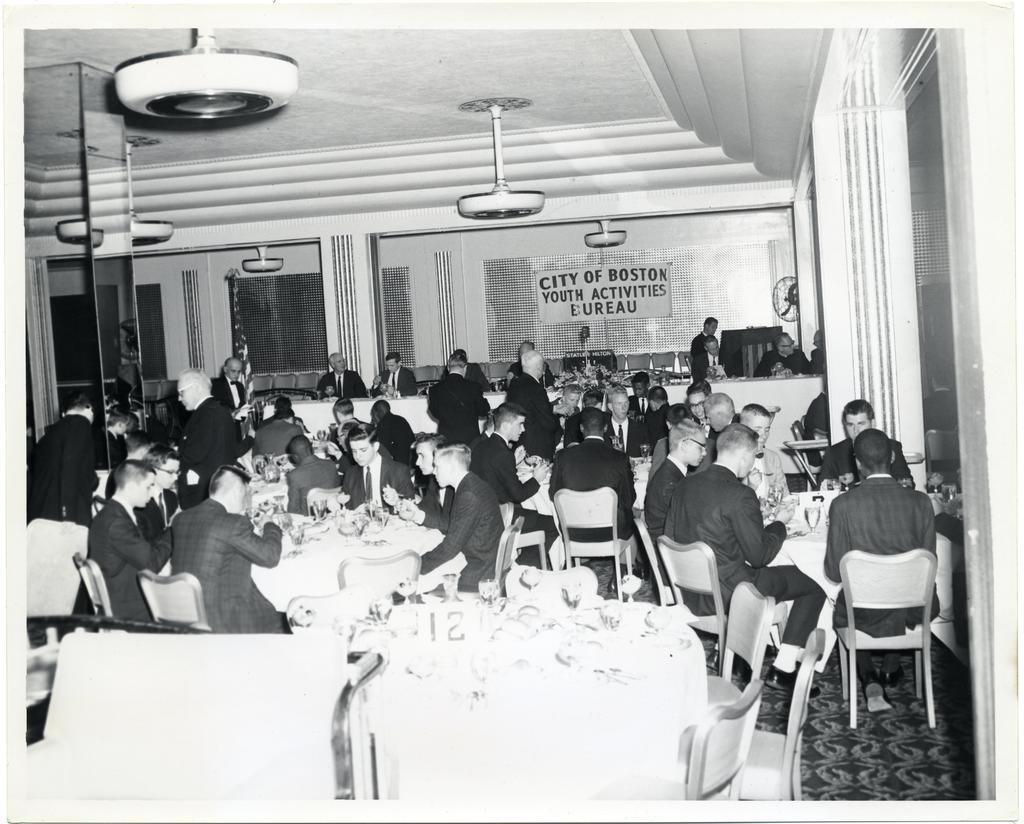Can you describe this image briefly? In this picture there are many persons sitting and having a dine on the chairs and dining table. It is a black and white picture there is chandelier hanging from ceiling and in the background i can see the beautiful doors with glass and there is banner hanging over on the wall of the door. The persons are dressed formal with blazers and trousers. 